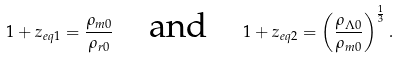Convert formula to latex. <formula><loc_0><loc_0><loc_500><loc_500>1 + z _ { e q 1 } = \frac { \rho _ { m 0 } } { \rho _ { r 0 } } \quad \text {and} \quad 1 + z _ { e q 2 } = \left ( \frac { \rho _ { \Lambda 0 } } { \rho _ { m 0 } } \right ) ^ { \frac { 1 } { 3 } } .</formula> 